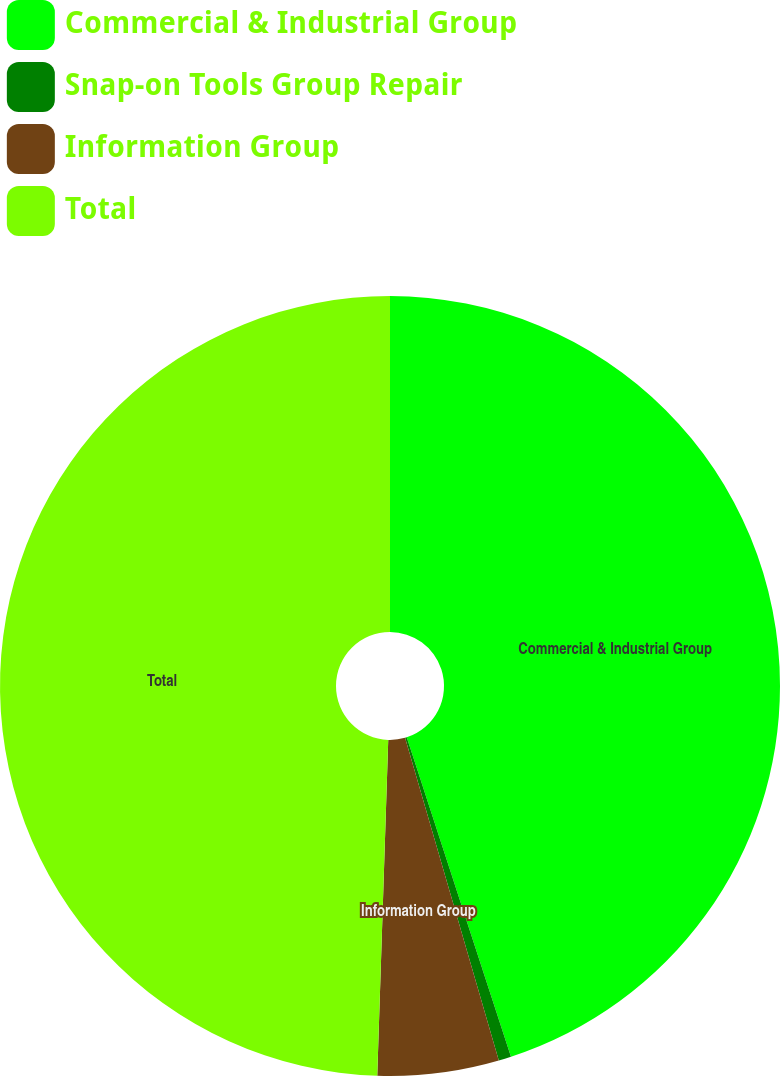Convert chart to OTSL. <chart><loc_0><loc_0><loc_500><loc_500><pie_chart><fcel>Commercial & Industrial Group<fcel>Snap-on Tools Group Repair<fcel>Information Group<fcel>Total<nl><fcel>44.98%<fcel>0.52%<fcel>5.02%<fcel>49.48%<nl></chart> 